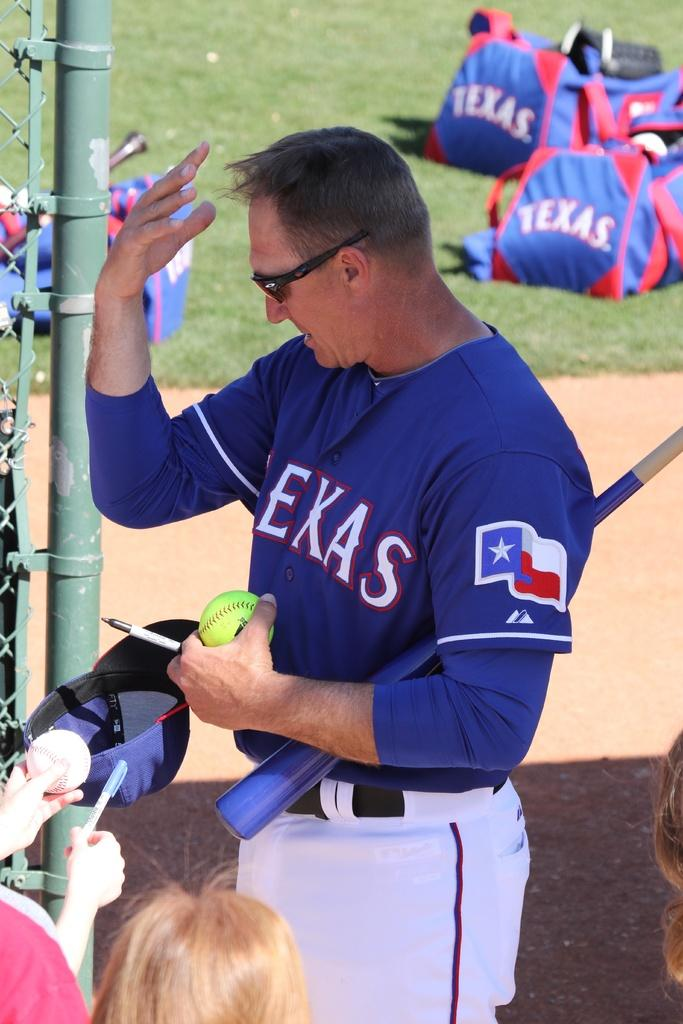<image>
Share a concise interpretation of the image provided. Man in a baseball uniform holding a ball and bat with his hand raised up to his forehead. 